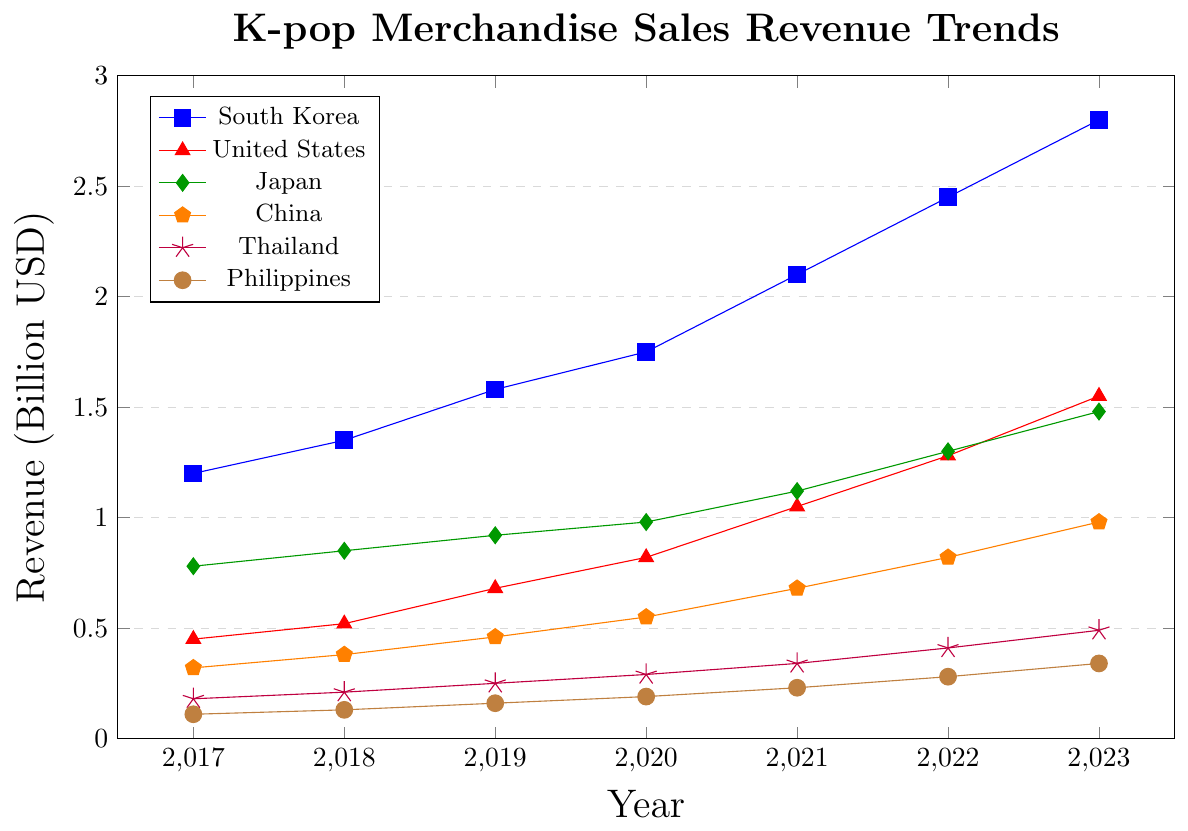Which country had the highest revenue from K-pop merchandise sales in 2023? Look at the 2023 data points on the chart and compare the revenue for each country. South Korea has the highest revenue at 2.8 billion USD.
Answer: South Korea Which country showed the most significant increase in revenue from 2017 to 2023? Calculate the difference in revenue for each country from 2017 to 2023. South Korea's increase is (2.8 - 1.2) billion USD which is 1.6 billion USD, the highest among all countries.
Answer: South Korea In which year did Japan's revenue from K-pop merchandise sales surpass 1 billion USD? Examine Japan's revenue trend line and identify the year when the value exceeds 1 billion USD. This occurs in 2021.
Answer: 2021 What was the combined revenue of China and Thailand in 2020? Sum up the revenue for China and Thailand in the year 2020: 0.55 billion USD (China) + 0.29 billion USD (Thailand) = 0.84 billion USD.
Answer: 0.84 billion USD Which country had the smallest revenue growth between 2017 and 2023? Calculate the revenue difference between 2017 and 2023 for each country. The Philippines' growth is the smallest: (0.34 - 0.11) billion USD = 0.23 billion USD.
Answer: Philippines Did any country see a decrease in revenue from one year to the next? Examine the trends of revenue for each country between consecutive years. There are no visible decreases across any of the years for any country; every year shows an increase in revenue.
Answer: No What is the approximate difference in revenue between the United States and Thailand in 2023? Look at the 2023 revenue values for the United States (1.55 billion USD) and Thailand (0.49 billion USD) and subtract the smaller value from the larger value: 1.55 - 0.49 = 1.06 billion USD.
Answer: 1.06 billion USD In which year did the United States surpass 1 billion USD in revenue from K-pop merchandise sales? Examine the United States' revenue trend line and identify the year when the value exceeds 1 billion USD. This occurs in 2021.
Answer: 2021 What's the average annual revenue for South Korea from 2017 to 2023? Sum the annual revenue values for South Korea from 2017 to 2023 and divide by the number of years: (1.2 + 1.35 + 1.58 + 1.75 + 2.1 + 2.45 + 2.8) / 7 = 13.23 / 7 ≈ 1.89 billion USD.
Answer: 1.89 billion USD 